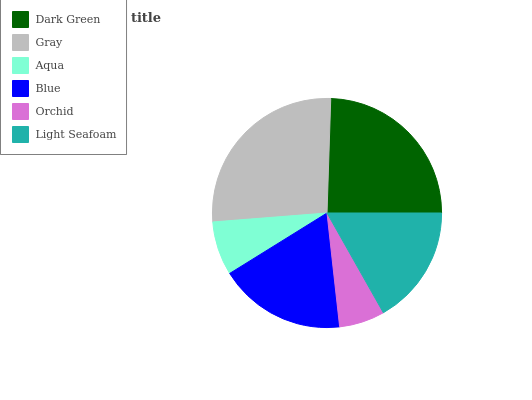Is Orchid the minimum?
Answer yes or no. Yes. Is Gray the maximum?
Answer yes or no. Yes. Is Aqua the minimum?
Answer yes or no. No. Is Aqua the maximum?
Answer yes or no. No. Is Gray greater than Aqua?
Answer yes or no. Yes. Is Aqua less than Gray?
Answer yes or no. Yes. Is Aqua greater than Gray?
Answer yes or no. No. Is Gray less than Aqua?
Answer yes or no. No. Is Blue the high median?
Answer yes or no. Yes. Is Light Seafoam the low median?
Answer yes or no. Yes. Is Aqua the high median?
Answer yes or no. No. Is Aqua the low median?
Answer yes or no. No. 